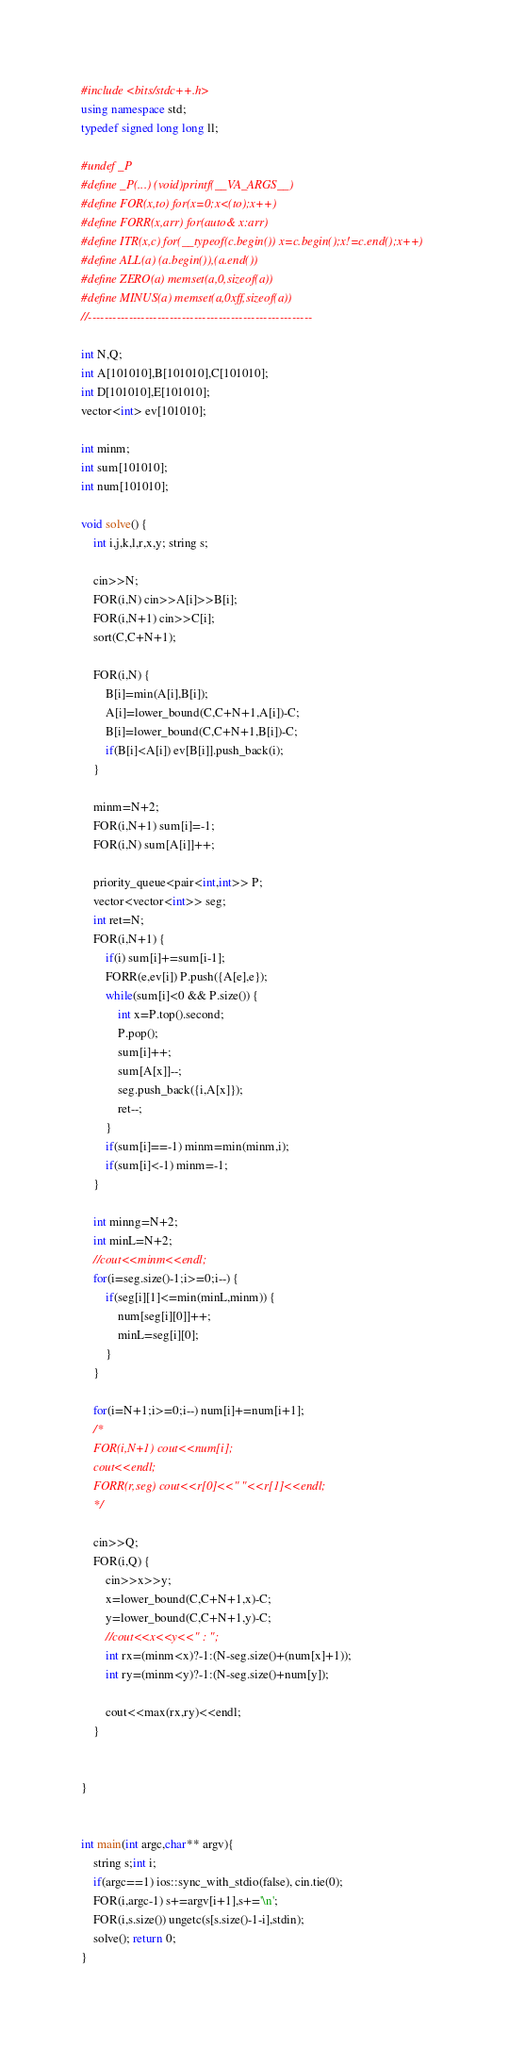<code> <loc_0><loc_0><loc_500><loc_500><_C++_>#include <bits/stdc++.h>
using namespace std;
typedef signed long long ll;

#undef _P
#define _P(...) (void)printf(__VA_ARGS__)
#define FOR(x,to) for(x=0;x<(to);x++)
#define FORR(x,arr) for(auto& x:arr)
#define ITR(x,c) for(__typeof(c.begin()) x=c.begin();x!=c.end();x++)
#define ALL(a) (a.begin()),(a.end())
#define ZERO(a) memset(a,0,sizeof(a))
#define MINUS(a) memset(a,0xff,sizeof(a))
//-------------------------------------------------------

int N,Q;
int A[101010],B[101010],C[101010];
int D[101010],E[101010];
vector<int> ev[101010];

int minm;
int sum[101010];
int num[101010];

void solve() {
	int i,j,k,l,r,x,y; string s;
	
	cin>>N;
	FOR(i,N) cin>>A[i]>>B[i];
	FOR(i,N+1) cin>>C[i];
	sort(C,C+N+1);
	
	FOR(i,N) {
		B[i]=min(A[i],B[i]);
		A[i]=lower_bound(C,C+N+1,A[i])-C;
		B[i]=lower_bound(C,C+N+1,B[i])-C;
		if(B[i]<A[i]) ev[B[i]].push_back(i);
	}
	
	minm=N+2;
	FOR(i,N+1) sum[i]=-1;
	FOR(i,N) sum[A[i]]++;
	
	priority_queue<pair<int,int>> P;
	vector<vector<int>> seg;
	int ret=N;
	FOR(i,N+1) {
		if(i) sum[i]+=sum[i-1];
		FORR(e,ev[i]) P.push({A[e],e});
		while(sum[i]<0 && P.size()) {
			int x=P.top().second;
			P.pop();
			sum[i]++;
			sum[A[x]]--;
			seg.push_back({i,A[x]});
			ret--;
		}
		if(sum[i]==-1) minm=min(minm,i);
		if(sum[i]<-1) minm=-1;
	}
	
	int minng=N+2;
	int minL=N+2;
	//cout<<minm<<endl;
	for(i=seg.size()-1;i>=0;i--) {
		if(seg[i][1]<=min(minL,minm)) {
			num[seg[i][0]]++;
			minL=seg[i][0];
		}
	}
	
	for(i=N+1;i>=0;i--) num[i]+=num[i+1];
	/*
	FOR(i,N+1) cout<<num[i];
	cout<<endl;
	FORR(r,seg) cout<<r[0]<<" "<<r[1]<<endl;
	*/
	
	cin>>Q;
	FOR(i,Q) {
		cin>>x>>y;
		x=lower_bound(C,C+N+1,x)-C;
		y=lower_bound(C,C+N+1,y)-C;
		//cout<<x<<y<<" : ";
		int rx=(minm<x)?-1:(N-seg.size()+(num[x]+1));
		int ry=(minm<y)?-1:(N-seg.size()+num[y]);
		
		cout<<max(rx,ry)<<endl;
	}
	
	
}


int main(int argc,char** argv){
	string s;int i;
	if(argc==1) ios::sync_with_stdio(false), cin.tie(0);
	FOR(i,argc-1) s+=argv[i+1],s+='\n';
	FOR(i,s.size()) ungetc(s[s.size()-1-i],stdin);
	solve(); return 0;
}
</code> 